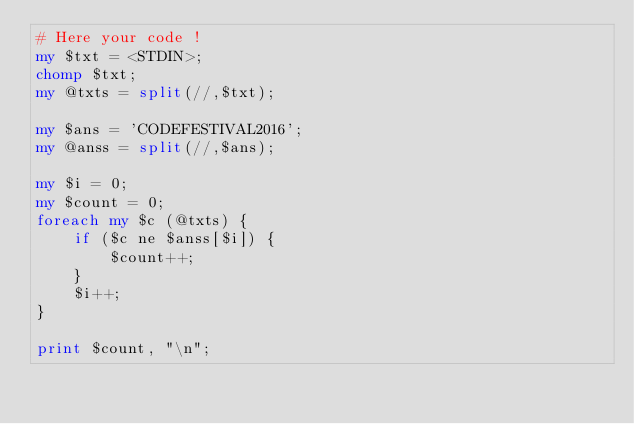<code> <loc_0><loc_0><loc_500><loc_500><_Perl_># Here your code !
my $txt = <STDIN>;
chomp $txt;
my @txts = split(//,$txt);

my $ans = 'CODEFESTIVAL2016';
my @anss = split(//,$ans);

my $i = 0;
my $count = 0;
foreach my $c (@txts) {
    if ($c ne $anss[$i]) {
        $count++;
    }
    $i++;
}

print $count, "\n";</code> 